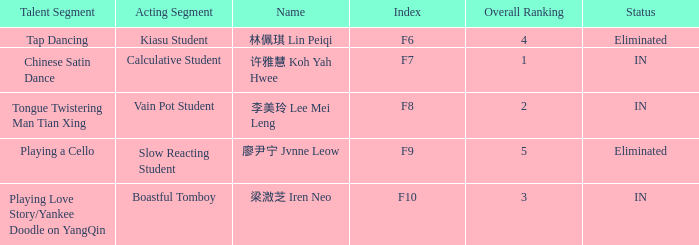For all events with index f10, what is the sum of the overall rankings? 3.0. 